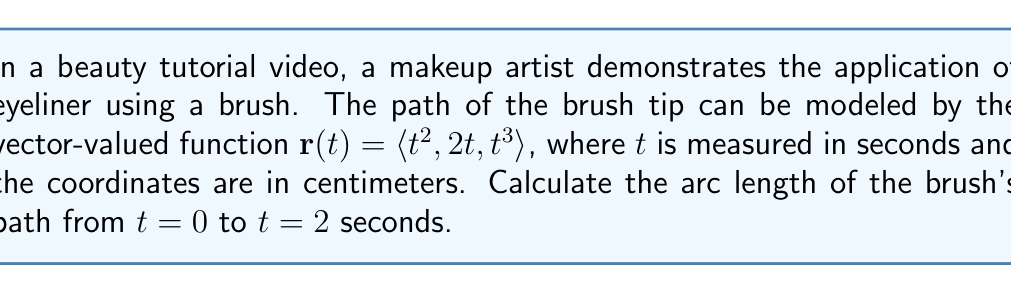Help me with this question. To find the arc length of a curve defined by a vector-valued function $\mathbf{r}(t)$ from $t=a$ to $t=b$, we use the formula:

$$ L = \int_a^b |\mathbf{r}'(t)| dt $$

where $\mathbf{r}'(t)$ is the derivative of $\mathbf{r}(t)$.

Step 1: Find $\mathbf{r}'(t)$
$\mathbf{r}'(t) = \langle 2t, 2, 3t^2 \rangle$

Step 2: Calculate $|\mathbf{r}'(t)|$
$|\mathbf{r}'(t)| = \sqrt{(2t)^2 + 2^2 + (3t^2)^2}$
$|\mathbf{r}'(t)| = \sqrt{4t^2 + 4 + 9t^4}$

Step 3: Set up the integral
$$ L = \int_0^2 \sqrt{4t^2 + 4 + 9t^4} dt $$

Step 4: This integral is difficult to evaluate analytically, so we'll use numerical integration. We can approximate the result using Simpson's Rule or a calculator with numerical integration capabilities.

Using a calculator or computer algebra system, we find:

$$ L \approx 7.26 \text{ cm} $$
Answer: The arc length of the brush's path from $t=0$ to $t=2$ seconds is approximately 7.26 cm. 